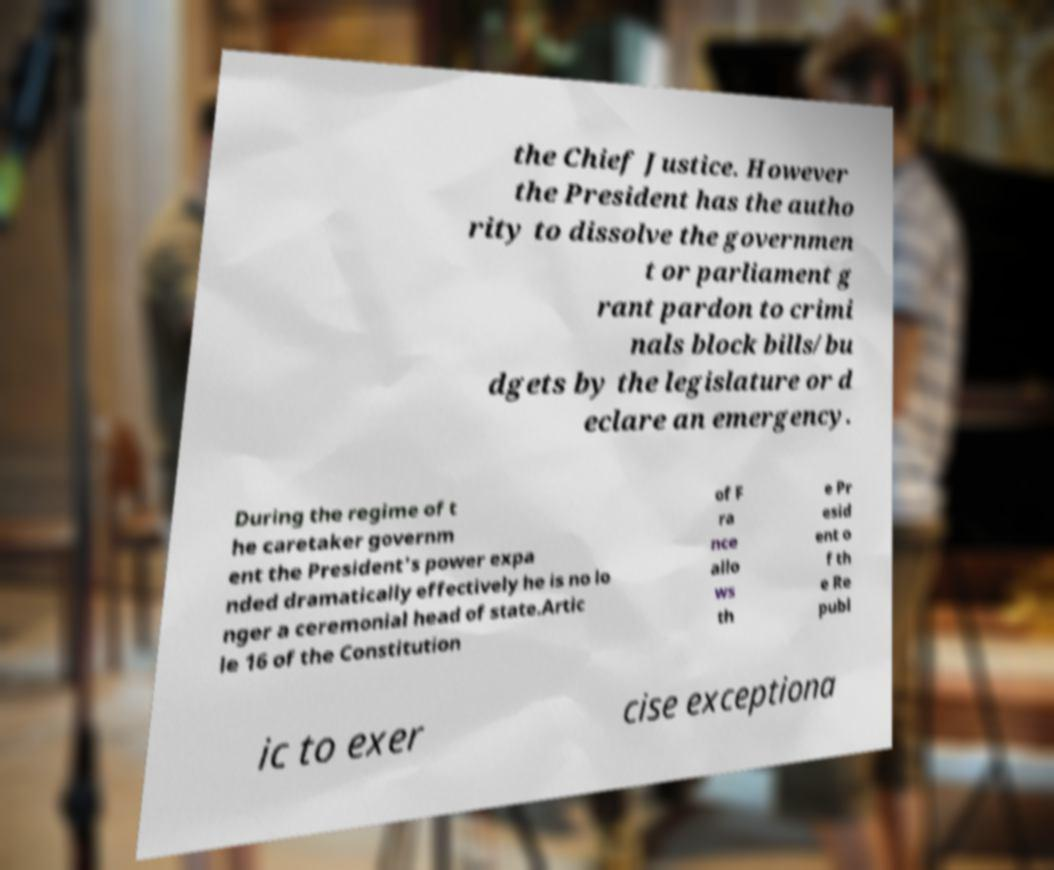Can you accurately transcribe the text from the provided image for me? the Chief Justice. However the President has the autho rity to dissolve the governmen t or parliament g rant pardon to crimi nals block bills/bu dgets by the legislature or d eclare an emergency. During the regime of t he caretaker governm ent the President's power expa nded dramatically effectively he is no lo nger a ceremonial head of state.Artic le 16 of the Constitution of F ra nce allo ws th e Pr esid ent o f th e Re publ ic to exer cise exceptiona 